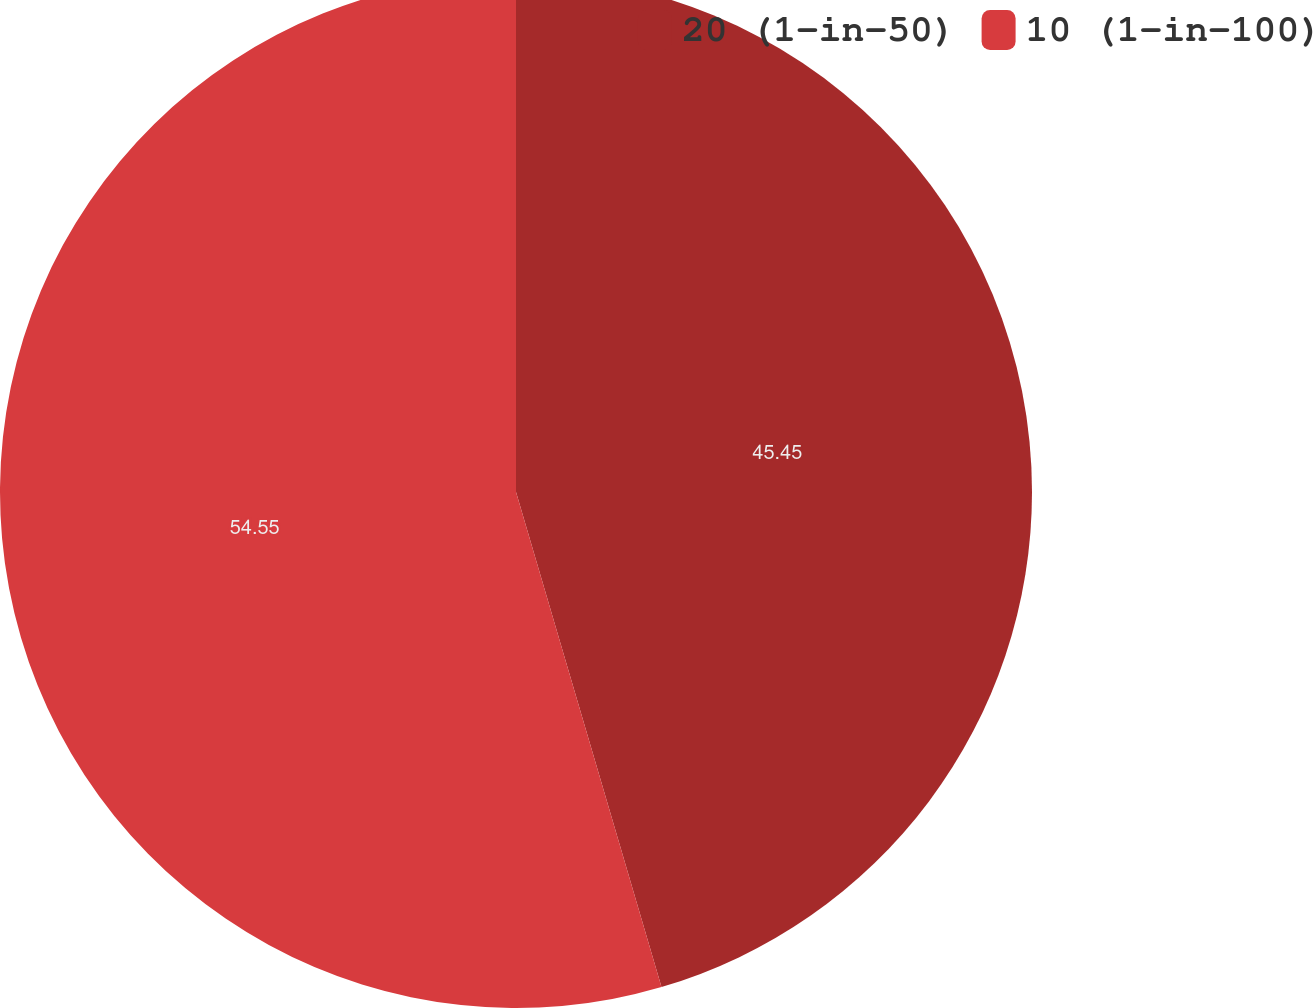<chart> <loc_0><loc_0><loc_500><loc_500><pie_chart><fcel>20 (1-in-50)<fcel>10 (1-in-100)<nl><fcel>45.45%<fcel>54.55%<nl></chart> 